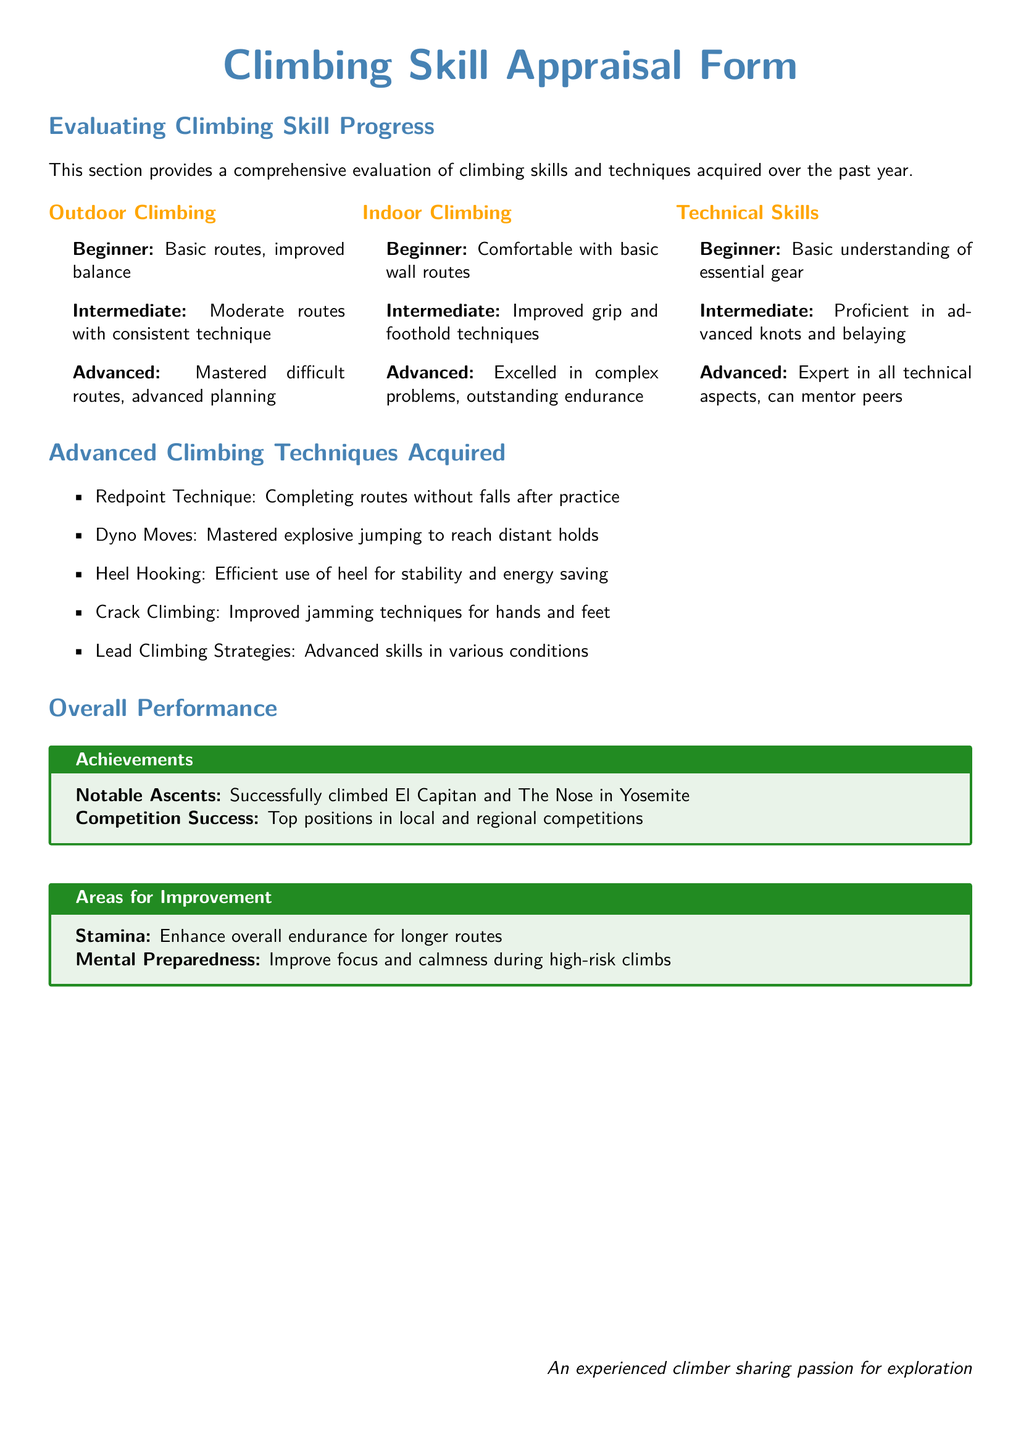What are the levels of outdoor climbing? The document lists three levels of outdoor climbing: Beginner, Intermediate, and Advanced.
Answer: Beginner, Intermediate, Advanced What notable ascents are mentioned? The document highlights successful climbs including El Capitan and The Nose in Yosemite.
Answer: El Capitan and The Nose What does "Redpoint Technique" refer to? It is defined as completing routes without falls after practice.
Answer: Completing routes without falls What is one area for improvement mentioned? The document specifies stamina as an area for improvement in climbing performance.
Answer: Stamina How many advanced climbing techniques are listed? The document provides five advanced climbing techniques that were acquired.
Answer: Five What is the primary focus of the "Overall Performance" section? It encompasses achievements and areas for improvement related to climbing skills.
Answer: Achievements and areas for improvement Which advanced technique focuses on explosive movement? The document refers to "Dyno Moves" as the advanced technique for explosive jumping.
Answer: Dyno Moves What skill is emphasized in "Heel Hooking"? Heel Hooking emphasizes efficient use of the heel for stability and energy saving.
Answer: Stability and energy saving 